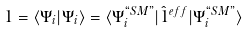<formula> <loc_0><loc_0><loc_500><loc_500>1 = \langle \Psi _ { i } | \Psi _ { i } \rangle = \langle \Psi _ { i } ^ { ` ` S M " } | \hat { 1 } ^ { e f f } | \Psi _ { i } ^ { ` ` S M " } \rangle</formula> 